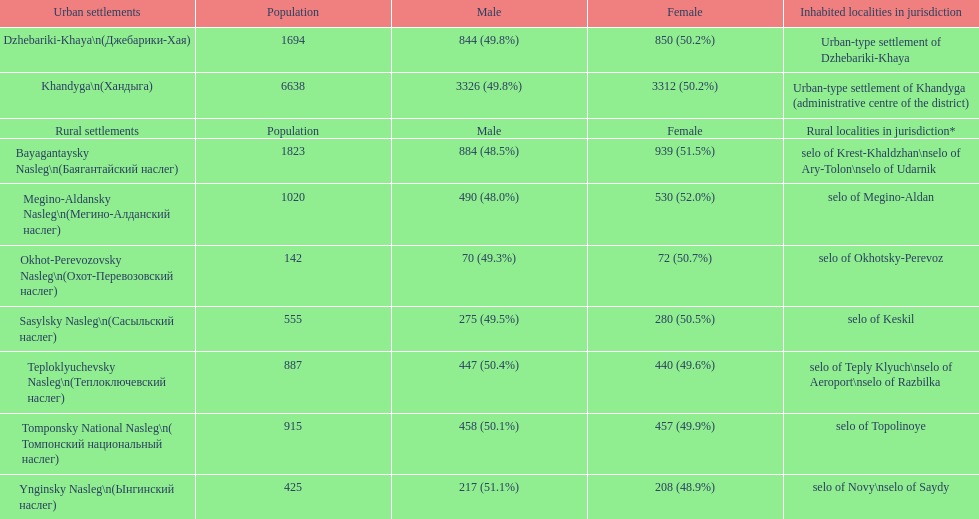What is the cumulative population count in dzhebariki-khaya? 1694. 